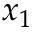Convert formula to latex. <formula><loc_0><loc_0><loc_500><loc_500>x _ { 1 }</formula> 